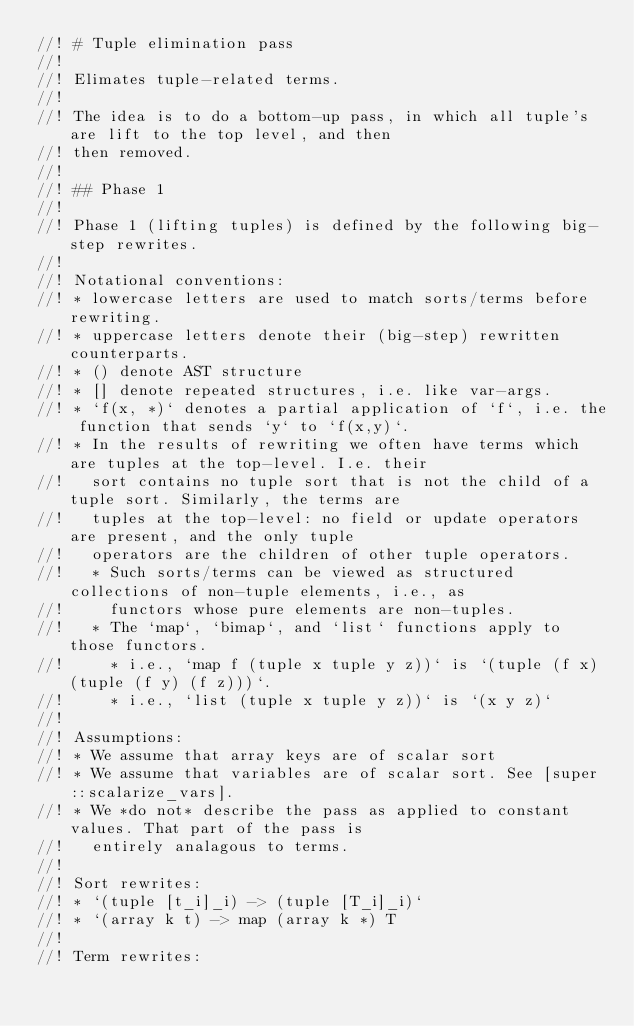Convert code to text. <code><loc_0><loc_0><loc_500><loc_500><_Rust_>//! # Tuple elimination pass
//!
//! Elimates tuple-related terms.
//!
//! The idea is to do a bottom-up pass, in which all tuple's are lift to the top level, and then
//! then removed.
//!
//! ## Phase 1
//!
//! Phase 1 (lifting tuples) is defined by the following big-step rewrites.
//!
//! Notational conventions:
//! * lowercase letters are used to match sorts/terms before rewriting.
//! * uppercase letters denote their (big-step) rewritten counterparts.
//! * () denote AST structure
//! * [] denote repeated structures, i.e. like var-args.
//! * `f(x, *)` denotes a partial application of `f`, i.e. the function that sends `y` to `f(x,y)`.
//! * In the results of rewriting we often have terms which are tuples at the top-level. I.e. their
//!   sort contains no tuple sort that is not the child of a tuple sort. Similarly, the terms are
//!   tuples at the top-level: no field or update operators are present, and the only tuple
//!   operators are the children of other tuple operators.
//!   * Such sorts/terms can be viewed as structured collections of non-tuple elements, i.e., as
//!     functors whose pure elements are non-tuples.
//!   * The `map`, `bimap`, and `list` functions apply to those functors.
//!     * i.e., `map f (tuple x tuple y z))` is `(tuple (f x) (tuple (f y) (f z)))`.
//!     * i.e., `list (tuple x tuple y z))` is `(x y z)`
//!
//! Assumptions:
//! * We assume that array keys are of scalar sort
//! * We assume that variables are of scalar sort. See [super::scalarize_vars].
//! * We *do not* describe the pass as applied to constant values. That part of the pass is
//!   entirely analagous to terms.
//!
//! Sort rewrites:
//! * `(tuple [t_i]_i) -> (tuple [T_i]_i)`
//! * `(array k t) -> map (array k *) T
//!
//! Term rewrites:</code> 